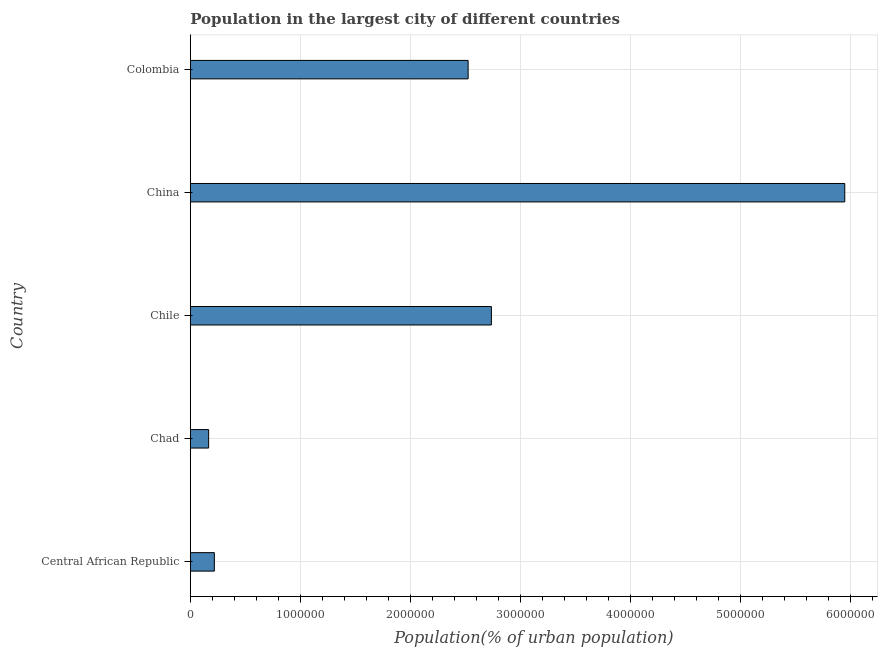Does the graph contain any zero values?
Make the answer very short. No. Does the graph contain grids?
Your response must be concise. Yes. What is the title of the graph?
Your response must be concise. Population in the largest city of different countries. What is the label or title of the X-axis?
Ensure brevity in your answer.  Population(% of urban population). What is the population in largest city in Chile?
Make the answer very short. 2.74e+06. Across all countries, what is the maximum population in largest city?
Keep it short and to the point. 5.95e+06. Across all countries, what is the minimum population in largest city?
Offer a very short reply. 1.67e+05. In which country was the population in largest city maximum?
Give a very brief answer. China. In which country was the population in largest city minimum?
Provide a succinct answer. Chad. What is the sum of the population in largest city?
Your response must be concise. 1.16e+07. What is the difference between the population in largest city in Chad and Chile?
Provide a short and direct response. -2.57e+06. What is the average population in largest city per country?
Offer a terse response. 2.32e+06. What is the median population in largest city?
Provide a short and direct response. 2.53e+06. What is the ratio of the population in largest city in Chad to that in Chile?
Your answer should be very brief. 0.06. Is the difference between the population in largest city in Central African Republic and Chad greater than the difference between any two countries?
Provide a succinct answer. No. What is the difference between the highest and the second highest population in largest city?
Offer a terse response. 3.21e+06. What is the difference between the highest and the lowest population in largest city?
Keep it short and to the point. 5.79e+06. In how many countries, is the population in largest city greater than the average population in largest city taken over all countries?
Give a very brief answer. 3. What is the difference between two consecutive major ticks on the X-axis?
Offer a terse response. 1.00e+06. What is the Population(% of urban population) in Central African Republic?
Your answer should be compact. 2.19e+05. What is the Population(% of urban population) in Chad?
Provide a succinct answer. 1.67e+05. What is the Population(% of urban population) in Chile?
Your answer should be very brief. 2.74e+06. What is the Population(% of urban population) in China?
Your answer should be compact. 5.95e+06. What is the Population(% of urban population) of Colombia?
Your response must be concise. 2.53e+06. What is the difference between the Population(% of urban population) in Central African Republic and Chad?
Your answer should be very brief. 5.20e+04. What is the difference between the Population(% of urban population) in Central African Republic and Chile?
Your answer should be very brief. -2.52e+06. What is the difference between the Population(% of urban population) in Central African Republic and China?
Provide a short and direct response. -5.73e+06. What is the difference between the Population(% of urban population) in Central African Republic and Colombia?
Provide a succinct answer. -2.31e+06. What is the difference between the Population(% of urban population) in Chad and Chile?
Give a very brief answer. -2.57e+06. What is the difference between the Population(% of urban population) in Chad and China?
Your answer should be compact. -5.79e+06. What is the difference between the Population(% of urban population) in Chad and Colombia?
Make the answer very short. -2.36e+06. What is the difference between the Population(% of urban population) in Chile and China?
Ensure brevity in your answer.  -3.21e+06. What is the difference between the Population(% of urban population) in Chile and Colombia?
Ensure brevity in your answer.  2.12e+05. What is the difference between the Population(% of urban population) in China and Colombia?
Your response must be concise. 3.43e+06. What is the ratio of the Population(% of urban population) in Central African Republic to that in Chad?
Offer a terse response. 1.31. What is the ratio of the Population(% of urban population) in Central African Republic to that in Chile?
Provide a short and direct response. 0.08. What is the ratio of the Population(% of urban population) in Central African Republic to that in China?
Provide a succinct answer. 0.04. What is the ratio of the Population(% of urban population) in Central African Republic to that in Colombia?
Your response must be concise. 0.09. What is the ratio of the Population(% of urban population) in Chad to that in Chile?
Provide a short and direct response. 0.06. What is the ratio of the Population(% of urban population) in Chad to that in China?
Give a very brief answer. 0.03. What is the ratio of the Population(% of urban population) in Chad to that in Colombia?
Make the answer very short. 0.07. What is the ratio of the Population(% of urban population) in Chile to that in China?
Your response must be concise. 0.46. What is the ratio of the Population(% of urban population) in Chile to that in Colombia?
Your answer should be compact. 1.08. What is the ratio of the Population(% of urban population) in China to that in Colombia?
Give a very brief answer. 2.36. 